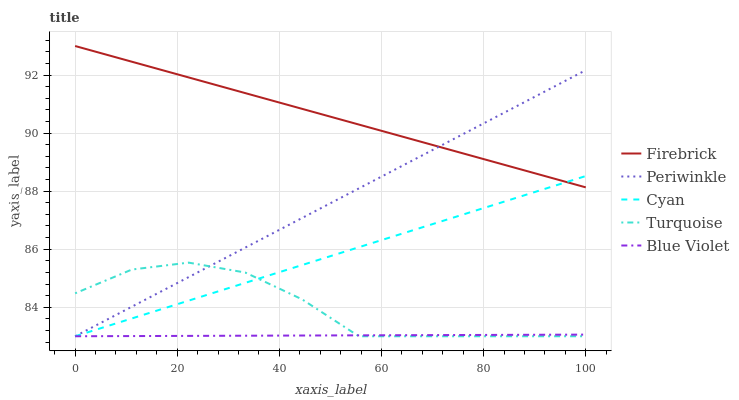Does Blue Violet have the minimum area under the curve?
Answer yes or no. Yes. Does Firebrick have the maximum area under the curve?
Answer yes or no. Yes. Does Periwinkle have the minimum area under the curve?
Answer yes or no. No. Does Periwinkle have the maximum area under the curve?
Answer yes or no. No. Is Blue Violet the smoothest?
Answer yes or no. Yes. Is Turquoise the roughest?
Answer yes or no. Yes. Is Firebrick the smoothest?
Answer yes or no. No. Is Firebrick the roughest?
Answer yes or no. No. Does Firebrick have the lowest value?
Answer yes or no. No. Does Firebrick have the highest value?
Answer yes or no. Yes. Does Periwinkle have the highest value?
Answer yes or no. No. Is Turquoise less than Firebrick?
Answer yes or no. Yes. Is Firebrick greater than Turquoise?
Answer yes or no. Yes. Does Turquoise intersect Cyan?
Answer yes or no. Yes. Is Turquoise less than Cyan?
Answer yes or no. No. Is Turquoise greater than Cyan?
Answer yes or no. No. Does Turquoise intersect Firebrick?
Answer yes or no. No. 